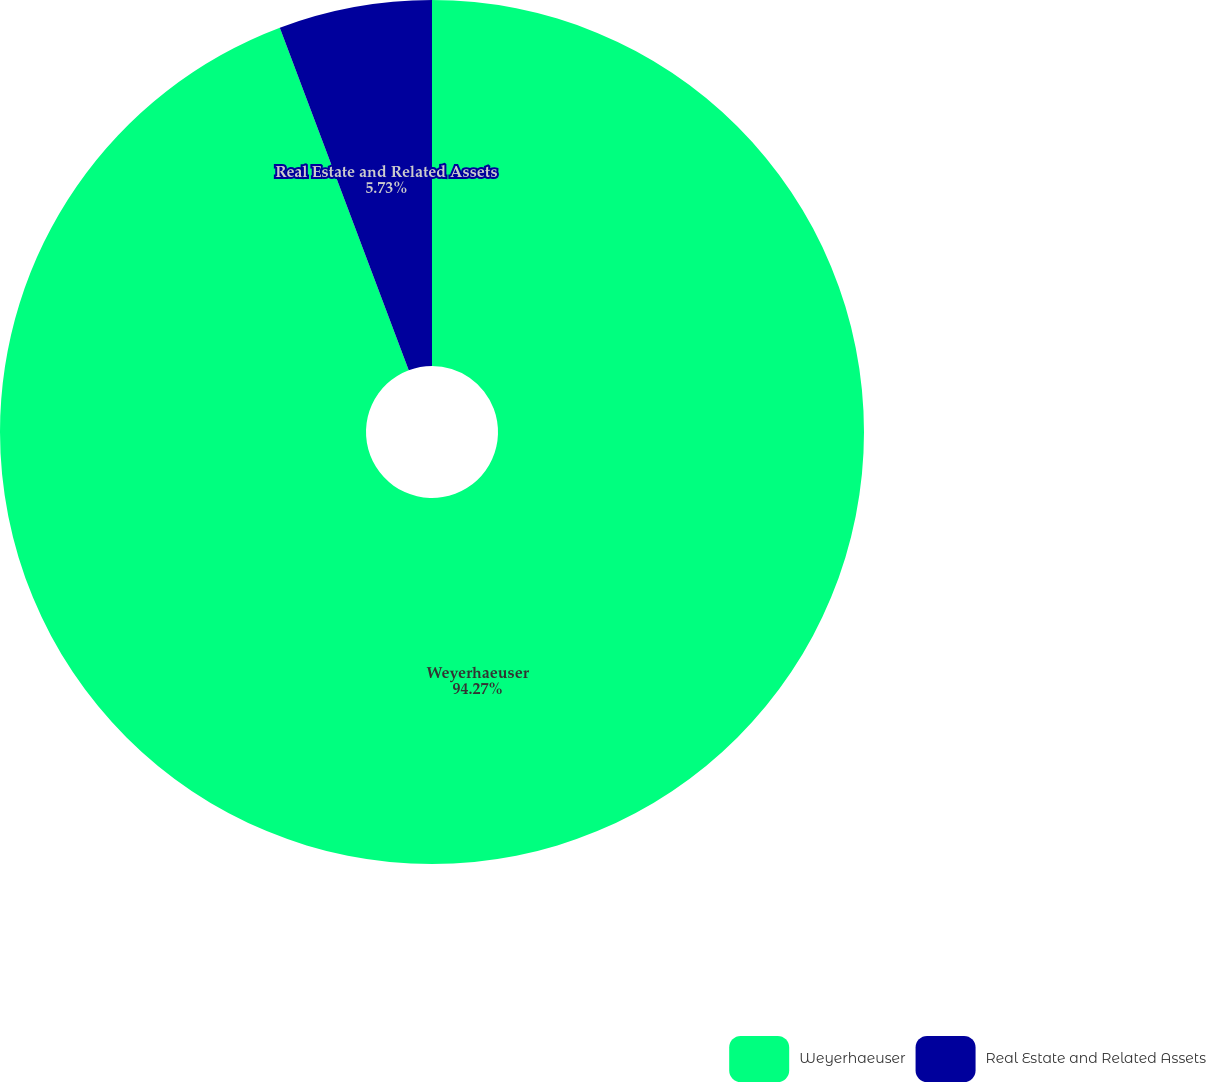Convert chart to OTSL. <chart><loc_0><loc_0><loc_500><loc_500><pie_chart><fcel>Weyerhaeuser<fcel>Real Estate and Related Assets<nl><fcel>94.27%<fcel>5.73%<nl></chart> 